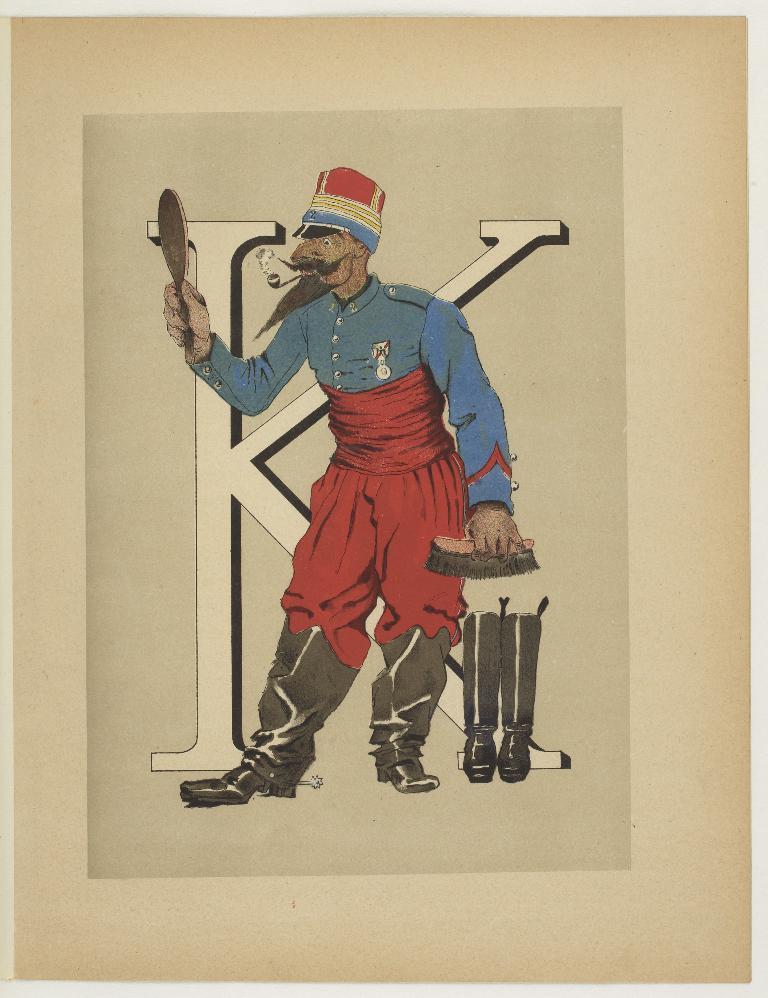Please provide a concise description of this image. In the center of this picture we can see the drawing of a person holding a mirror and a brush and standing on the ground and we can see the boots are placed on the ground. In the background there is an alphabet K and the background of the image is white in color. 